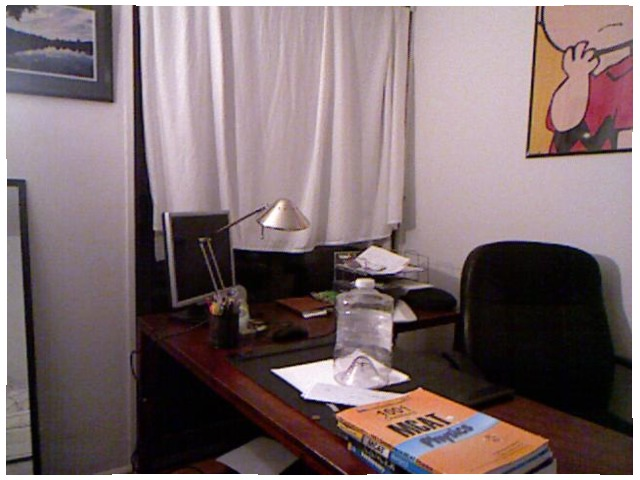<image>
Is the water bottle under the desk? No. The water bottle is not positioned under the desk. The vertical relationship between these objects is different. Where is the picture in relation to the wall? Is it on the wall? Yes. Looking at the image, I can see the picture is positioned on top of the wall, with the wall providing support. Where is the chair in relation to the table? Is it on the table? No. The chair is not positioned on the table. They may be near each other, but the chair is not supported by or resting on top of the table. 